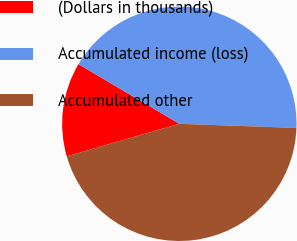Convert chart. <chart><loc_0><loc_0><loc_500><loc_500><pie_chart><fcel>(Dollars in thousands)<fcel>Accumulated income (loss)<fcel>Accumulated other<nl><fcel>12.98%<fcel>42.06%<fcel>44.96%<nl></chart> 